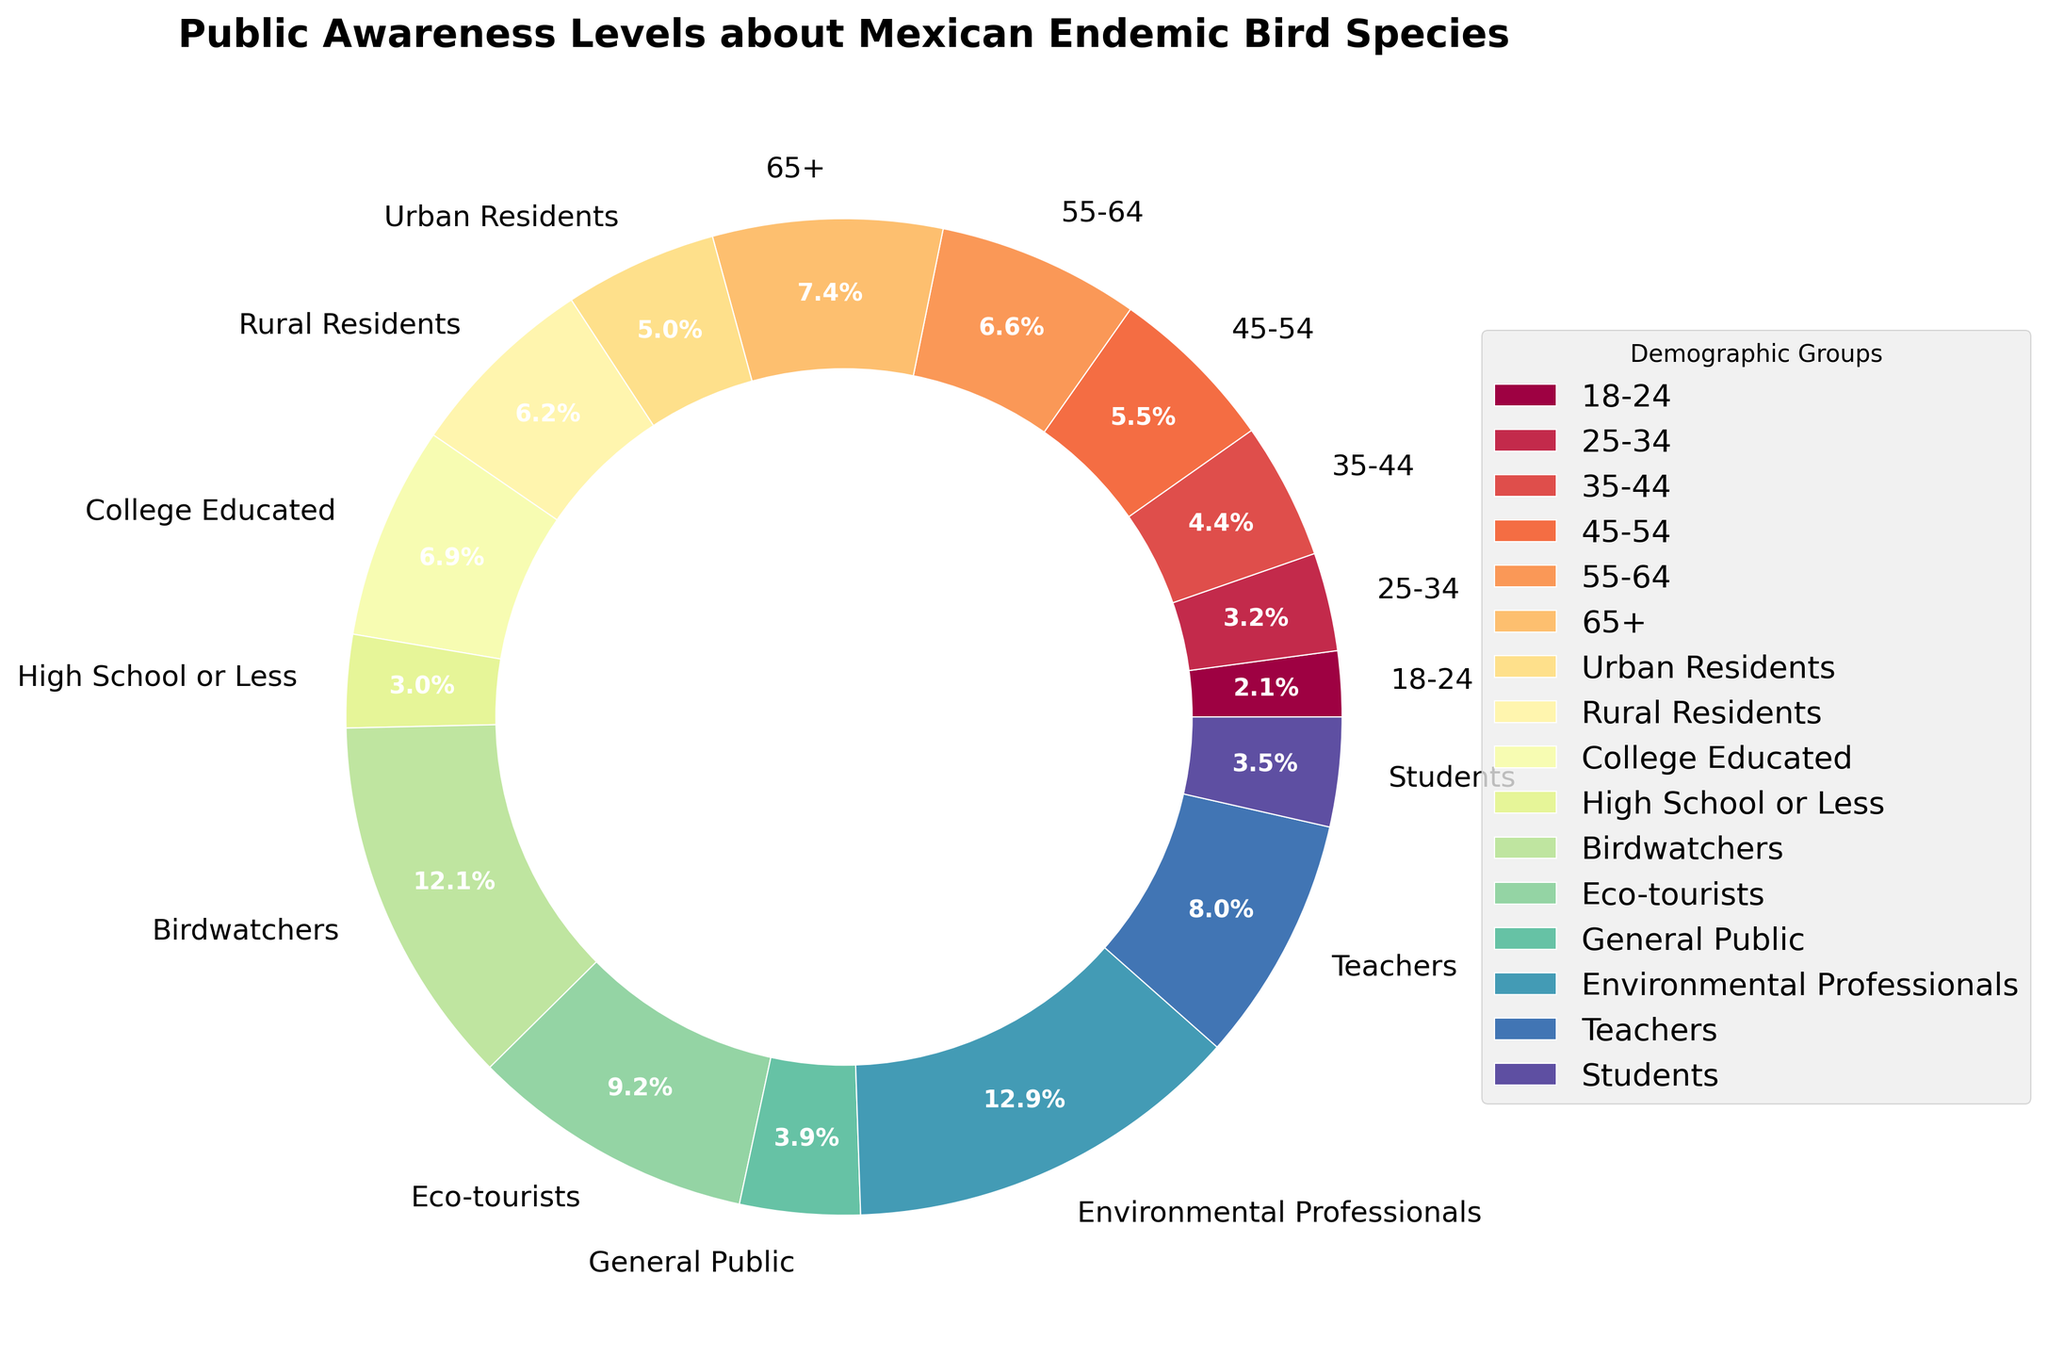What is the public awareness level percentage among environmental professionals? The public awareness level for each demographic group is displayed on the pie chart. The segment labeled "Environmental Professionals" indicates that their awareness level is 73%.
Answer: 73% Which group has the lowest public awareness level about Mexican endemic bird species? By examining the pie chart, the segment labeled "18-24" has the smallest percentage, indicated as 12%.
Answer: 18-24 Compare the awareness levels between birdwatchers and eco-tourists. Which group has a higher awareness? The pie chart shows the segment labeled "Birdwatchers" with an awareness level of 68%. The segment labeled "Eco-tourists" has an awareness level of 52%. Therefore, birdwatchers have a higher awareness.
Answer: Birdwatchers What is the average awareness level of the age groups (18-24, 25-34, 35-44, 45-54, 55-64, 65+)? Combine the awareness levels of the age groups: 12%, 18%, 25%, 31%, 37%, and 42%. Sum them up: 12 + 18 + 25 + 31 + 37 + 42 = 165. There are 6 groups, so the average is 165 / 6.
Answer: 27.5% What is the visual difference in color between the segments representing urban residents and rural residents? The pie chart displays each demographic group with distinct colors. The segment for "Urban Residents" has one color, and "Rural Residents" has another. Noting the assigned colors from the figure, the specific shades can be identified visually.
Answer: Different colors (specific color names can be identified visually) What is the difference in public awareness levels between the general public and teachers? The segment labeled "General Public" shows a level of 22%, and the segment labeled "Teachers" shows a level of 45%. The difference is 45% - 22%.
Answer: 23% Among the age groups, which one has the highest awareness level? By examining the pie chart, the segment labeled "65+" has the highest percentage, indicated as 42%.
Answer: 65+ What is the proportion of the awareness level of students to the general public? The pie chart shows the segment labeled "Students" with an awareness level of 20%, and "General Public" with a level of 22%. The proportion is calculated as 20 / 22.
Answer: 0.91 (or approximately 91%) Which demographic group has an awareness level close to 50%? The pie chart shows that the segment labeled "Eco-tourists" has an awareness level of 52%, which is close to 50%.
Answer: Eco-tourists Calculate the total percentage of awareness levels represented in the pie chart for all demographic groups combined. The percentage values are listed for each segment: 12, 18, 25, 31, 37, 42, 28, 35, 39, 17, 68, 52, 22, 73, 45, 20. Adding these values gives the total: 12 + 18 + 25 + 31 + 37 + 42 + 28 + 35 + 39 + 17 + 68 + 52 + 22 + 73 + 45 + 20 = 564.
Answer: 564% 